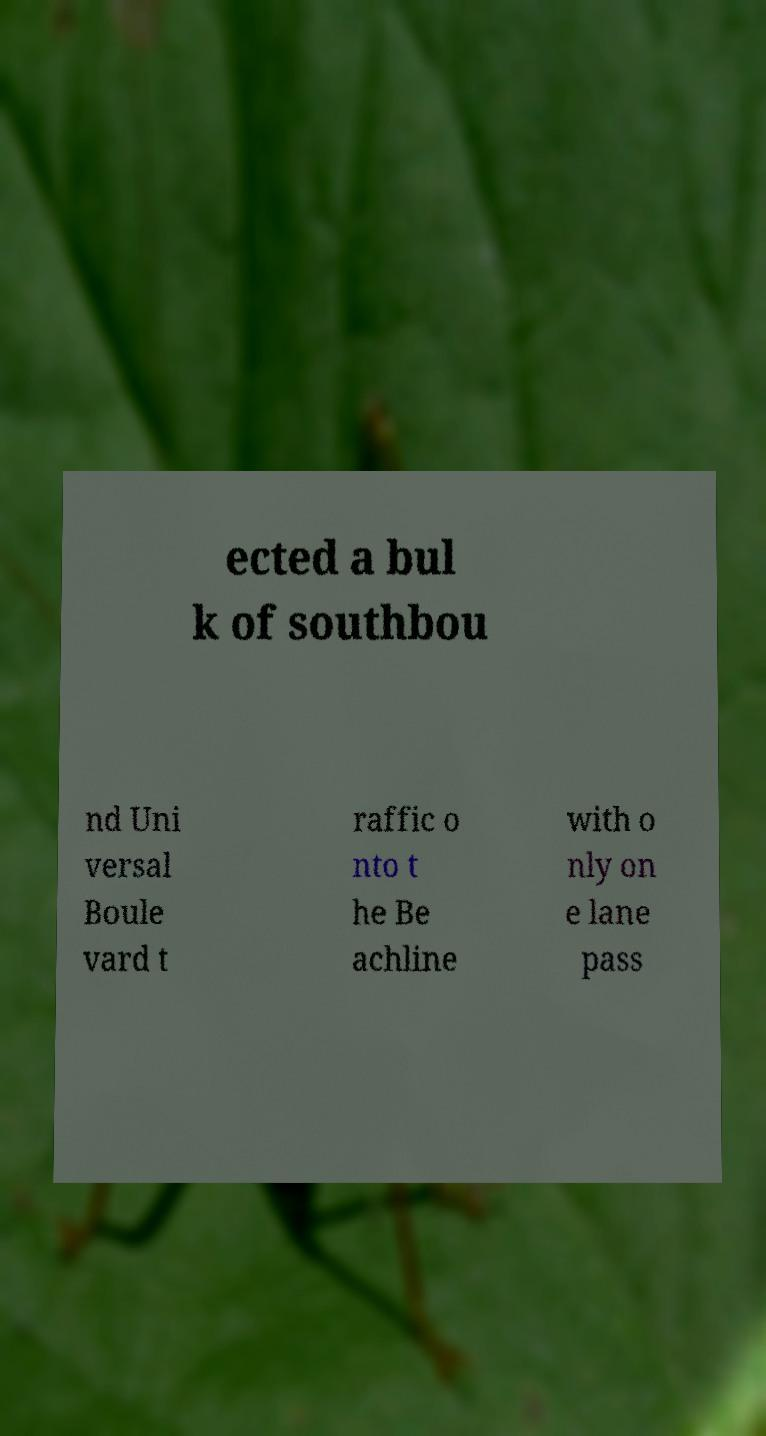Can you read and provide the text displayed in the image?This photo seems to have some interesting text. Can you extract and type it out for me? ected a bul k of southbou nd Uni versal Boule vard t raffic o nto t he Be achline with o nly on e lane pass 